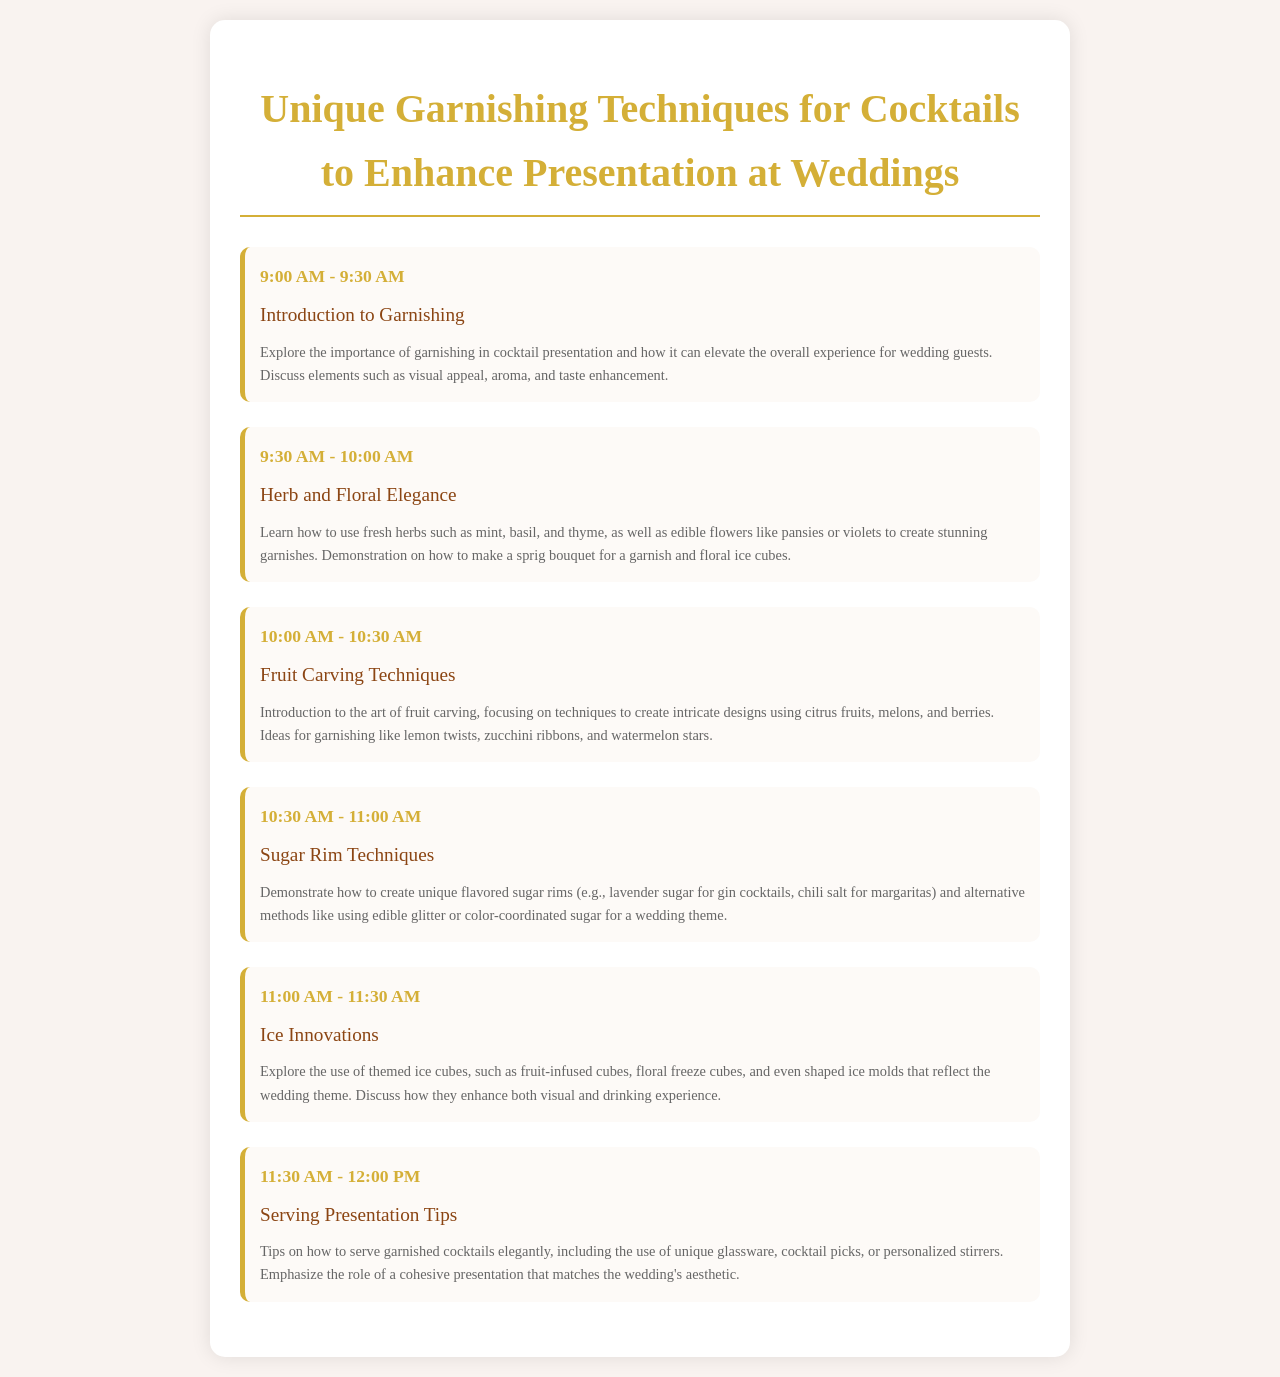what is the title of the document? The title of the document is indicated at the top of the rendered HTML.
Answer: Unique Garnishing Techniques for Cocktails to Enhance Presentation at Weddings what time does the Introduction to Garnishing start? The schedule specifies the starting time for each item, and the Introduction to Garnishing starts at 9:00 AM.
Answer: 9:00 AM how long is the session on Herb and Floral Elegance? The duration of each session can be found in the schedule, and Herb and Floral Elegance lasts for 30 minutes.
Answer: 30 minutes which technique is focused on crafting unique flavored sugar rims? The schedule mentions a specific session that covers this technique, which is Sugar Rim Techniques.
Answer: Sugar Rim Techniques what kind of ice innovations are discussed? The Ice Innovations section describes various types of themed ice cubes.
Answer: themed ice cubes how many total sessions are scheduled? By counting each session listed in the schedule, we find there are six total sessions.
Answer: six what is used to create unique glassware presentations? The Serving Presentation Tips section provides various methods, specifically including unique glassware.
Answer: unique glassware which herbs are mentioned for use in garnishes? The Herb and Floral Elegance session lists specific herbs, including mint, basil, and thyme.
Answer: mint, basil, thyme 